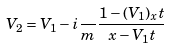Convert formula to latex. <formula><loc_0><loc_0><loc_500><loc_500>V _ { 2 } = V _ { 1 } - i \frac { } { m } \frac { 1 - ( V _ { 1 } ) _ { x } t } { x - V _ { 1 } t }</formula> 